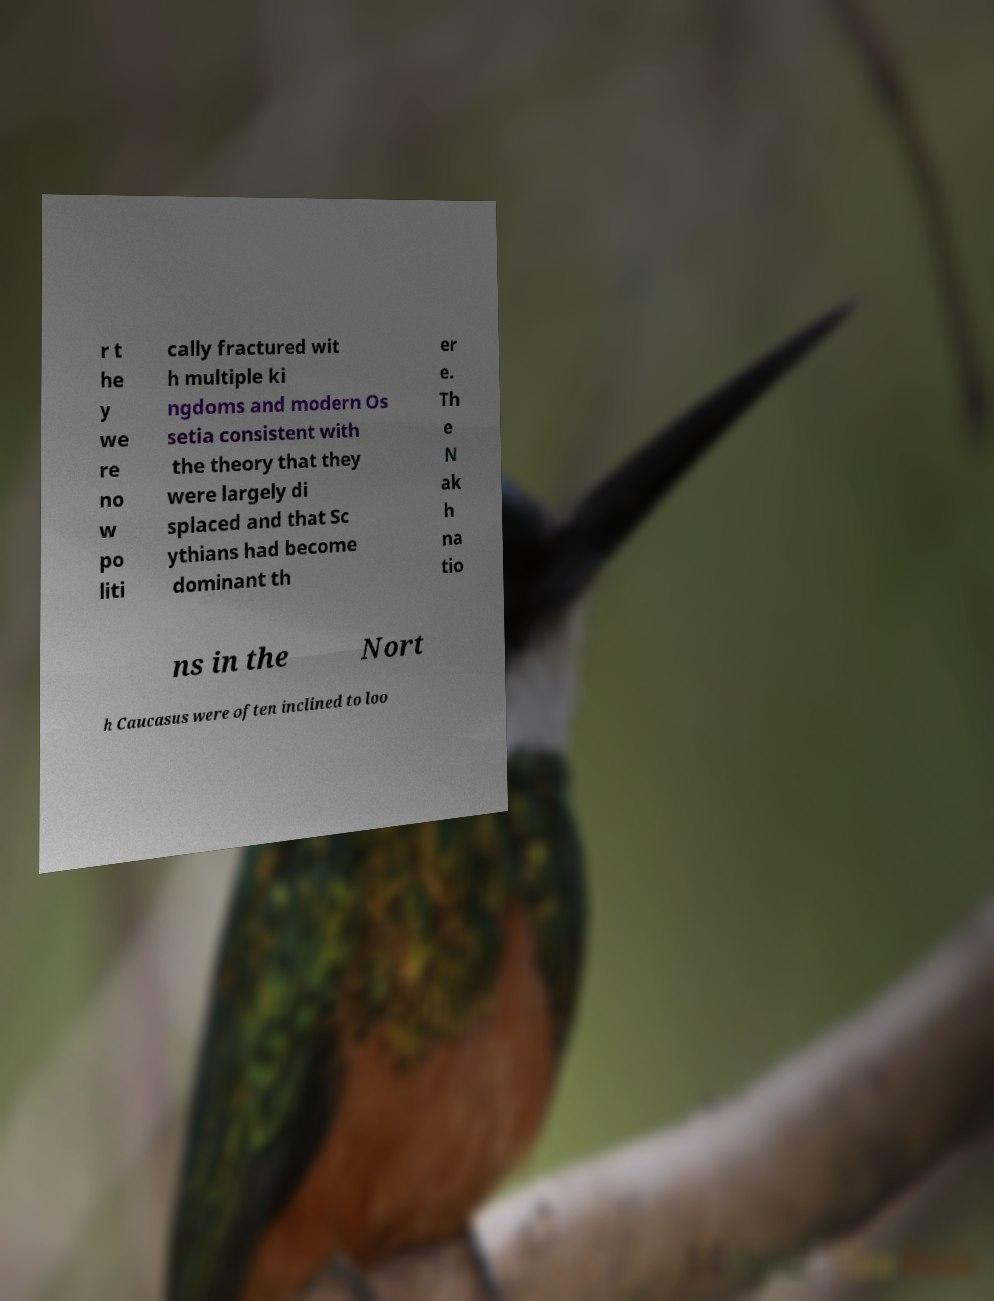Can you accurately transcribe the text from the provided image for me? r t he y we re no w po liti cally fractured wit h multiple ki ngdoms and modern Os setia consistent with the theory that they were largely di splaced and that Sc ythians had become dominant th er e. Th e N ak h na tio ns in the Nort h Caucasus were often inclined to loo 